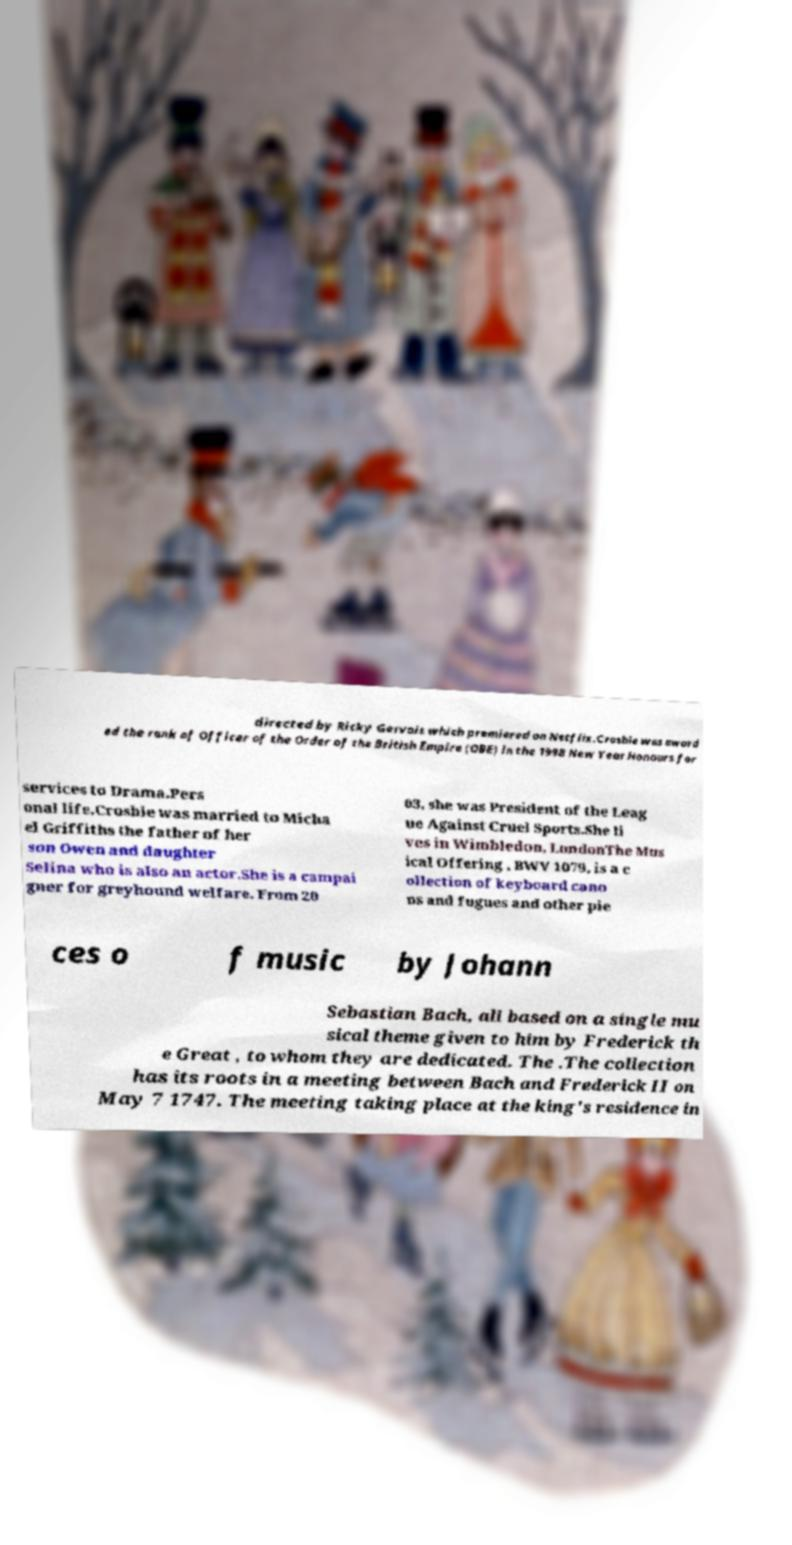Can you accurately transcribe the text from the provided image for me? directed by Ricky Gervais which premiered on Netflix.Crosbie was award ed the rank of Officer of the Order of the British Empire (OBE) in the 1998 New Year Honours for services to Drama.Pers onal life.Crosbie was married to Micha el Griffiths the father of her son Owen and daughter Selina who is also an actor.She is a campai gner for greyhound welfare. From 20 03, she was President of the Leag ue Against Cruel Sports.She li ves in Wimbledon, LondonThe Mus ical Offering , BWV 1079, is a c ollection of keyboard cano ns and fugues and other pie ces o f music by Johann Sebastian Bach, all based on a single mu sical theme given to him by Frederick th e Great , to whom they are dedicated. The .The collection has its roots in a meeting between Bach and Frederick II on May 7 1747. The meeting taking place at the king's residence in 